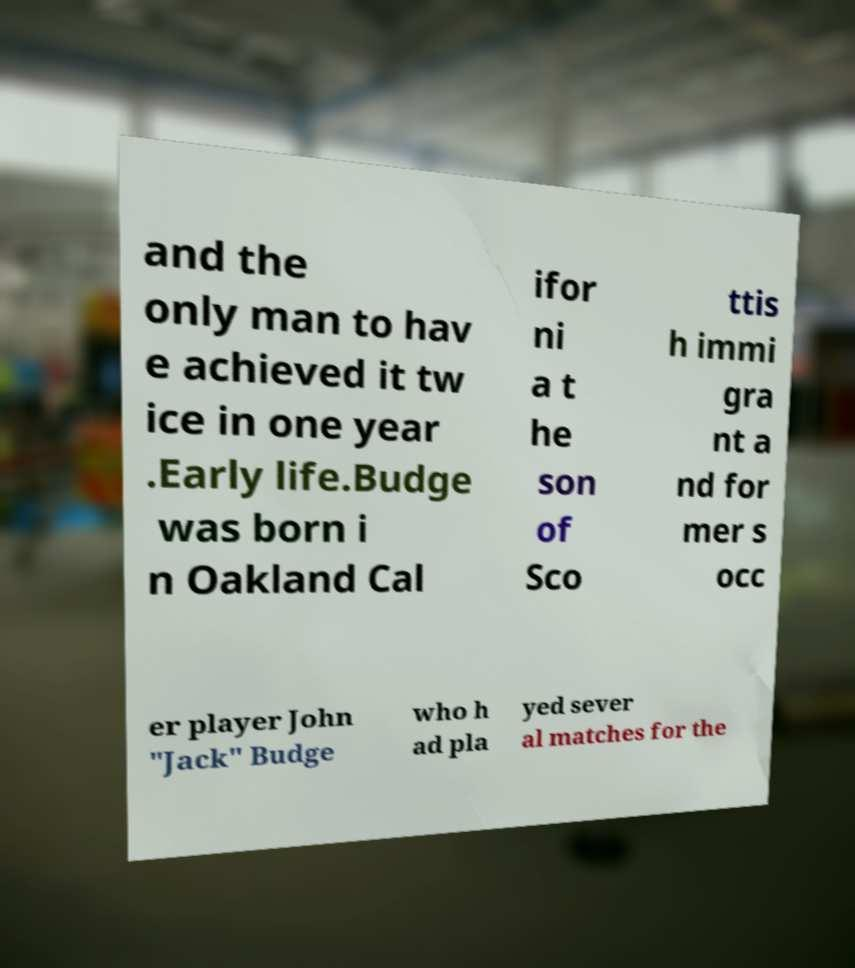For documentation purposes, I need the text within this image transcribed. Could you provide that? and the only man to hav e achieved it tw ice in one year .Early life.Budge was born i n Oakland Cal ifor ni a t he son of Sco ttis h immi gra nt a nd for mer s occ er player John "Jack" Budge who h ad pla yed sever al matches for the 